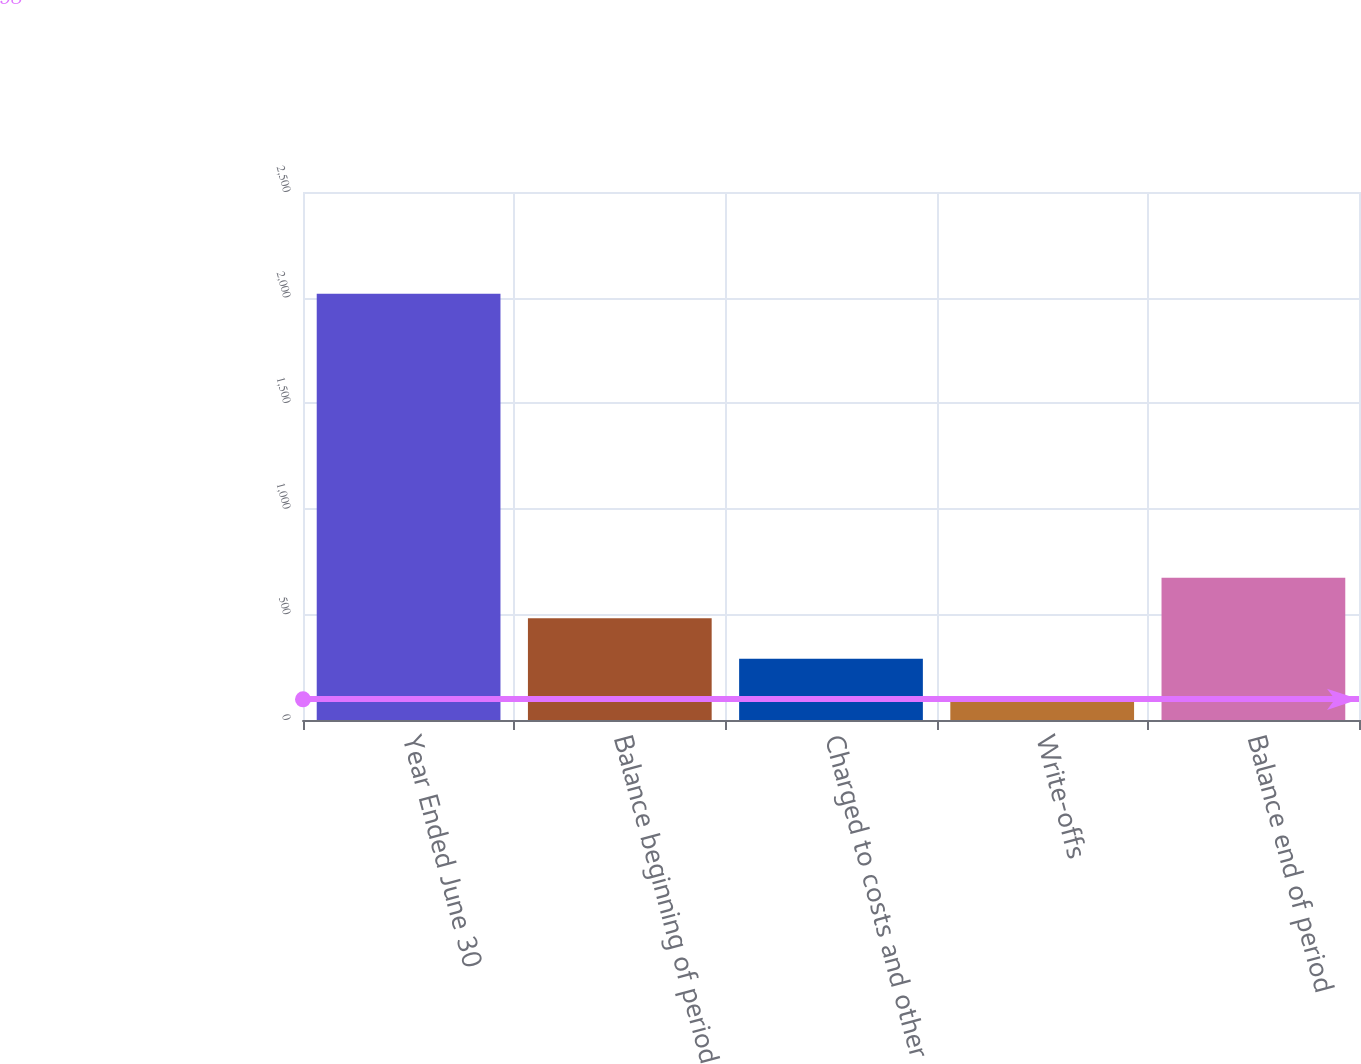Convert chart. <chart><loc_0><loc_0><loc_500><loc_500><bar_chart><fcel>Year Ended June 30<fcel>Balance beginning of period<fcel>Charged to costs and other<fcel>Write-offs<fcel>Balance end of period<nl><fcel>2018<fcel>482<fcel>290<fcel>98<fcel>674<nl></chart> 